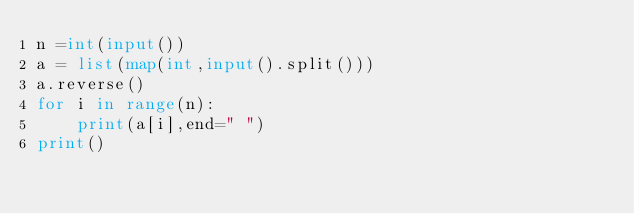Convert code to text. <code><loc_0><loc_0><loc_500><loc_500><_Python_>n =int(input())
a = list(map(int,input().split()))
a.reverse()
for i in range(n):
    print(a[i],end=" ")
print()</code> 